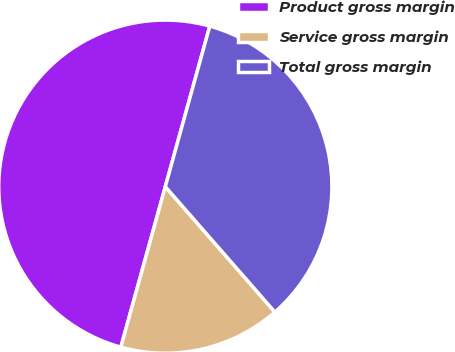Convert chart to OTSL. <chart><loc_0><loc_0><loc_500><loc_500><pie_chart><fcel>Product gross margin<fcel>Service gross margin<fcel>Total gross margin<nl><fcel>50.0%<fcel>15.73%<fcel>34.27%<nl></chart> 